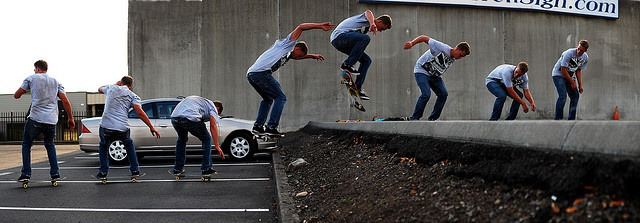Describe the objects in this image and their specific colors. I can see car in white, black, darkgray, gray, and lightgray tones, people in white, black, and gray tones, people in white, black, darkgray, maroon, and gray tones, people in white, black, darkgray, and gray tones, and people in white, black, gray, navy, and maroon tones in this image. 